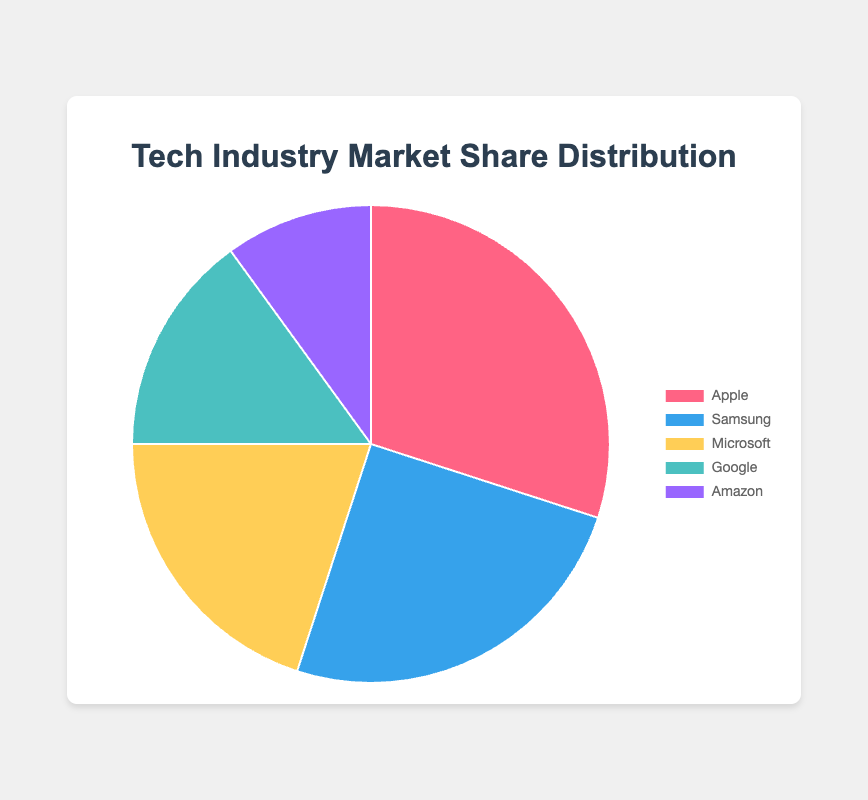Which company has the largest market share? Apple has the largest market share at 30%, as shown by the biggest segment in the pie chart.
Answer: Apple Which company has the smallest market share? Amazon has the smallest market share at 10%, as indicated by the smallest segment in the pie chart.
Answer: Amazon What is the combined market share of Apple and Samsung? The combined market share is obtained by adding Apple's 30% and Samsung's 25%, resulting in 55%.
Answer: 55% What is the difference in market share between Microsoft and Google? The difference is calculated by subtracting Google's 15% from Microsoft's 20%, which equals 5%.
Answer: 5% Which companies together hold a market share greater than 50%? Apple (30%) and Samsung (25%) together hold a market share of 55%, which is greater than 50%.
Answer: Apple and Samsung What is the average market share among all companies? Add up all the percentages: 30% + 25% + 20% + 15% + 10% = 100%. Then divide by the number of companies, which is 5, resulting in an average market share of 20%.
Answer: 20% Which company holds exactly twice the market share of Amazon? Apple holds exactly 30%, which is twice Amazon's 10%.
Answer: Apple How much greater is Samsung's market share compared to Google's? Subtract Google's 15% from Samsung's 25%, resulting in a difference of 10%.
Answer: 10% What is the total market share of companies other than Apple? Sum the market shares of Samsung, Microsoft, Google, and Amazon: 25% + 20% + 15% + 10% = 70%.
Answer: 70% Which segment is represented by the color red in the pie chart? The segment represented by the color red in the pie chart corresponds to Apple, which has the largest segment.
Answer: Apple 